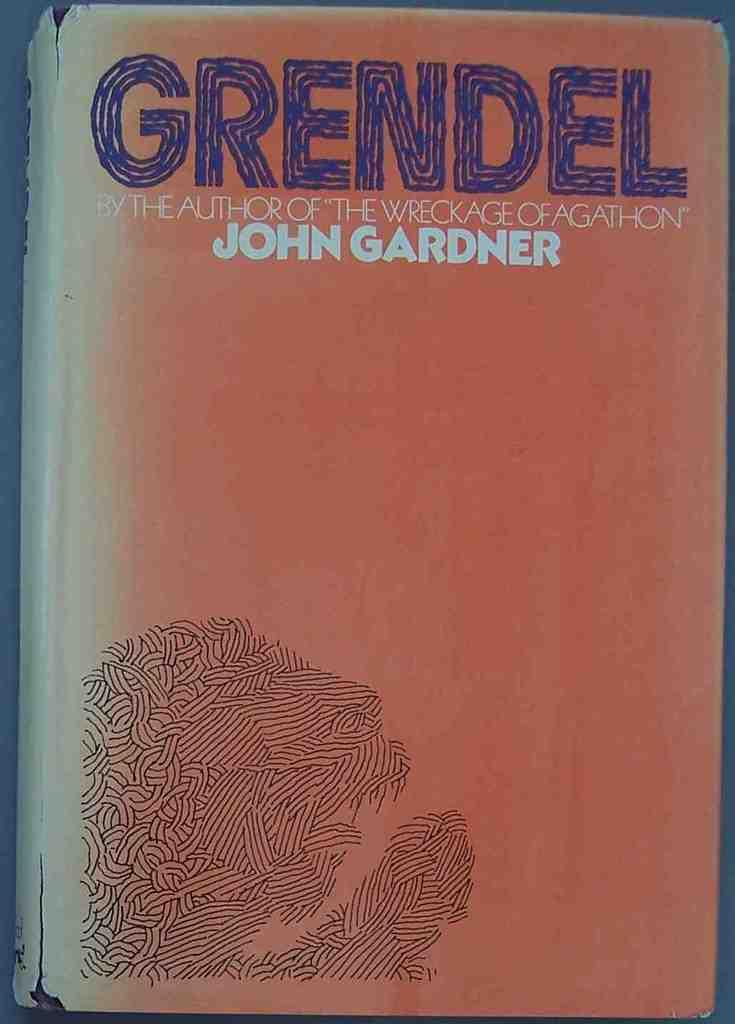<image>
Write a terse but informative summary of the picture. The cover of the book titled Grendel Written by John Gardner. 